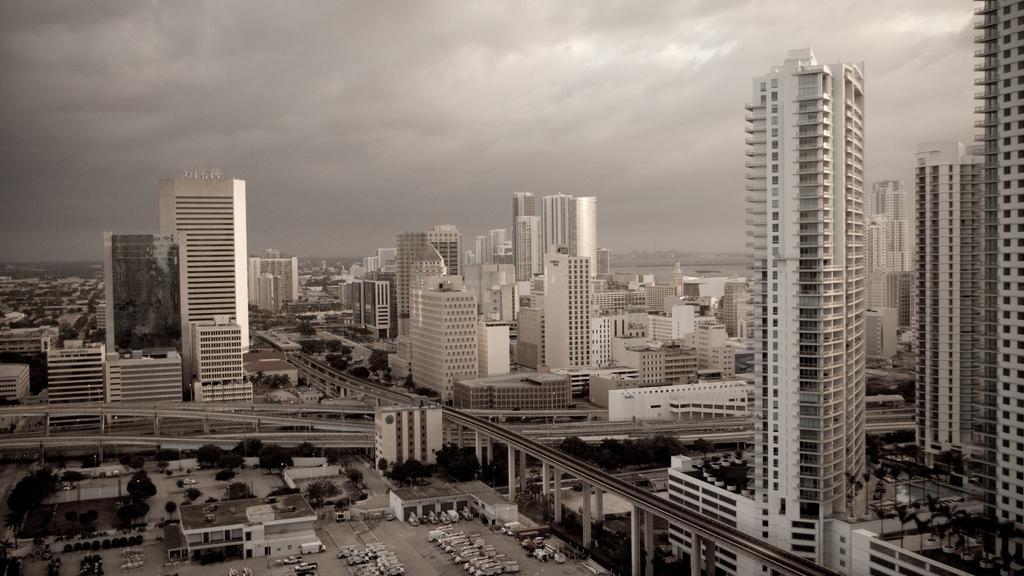How would you summarize this image in a sentence or two? This is a black and white image. In this image we can see sky with clouds, buildings, skyscrapers, poles, trees, roads and motor vehicles on the floor. 